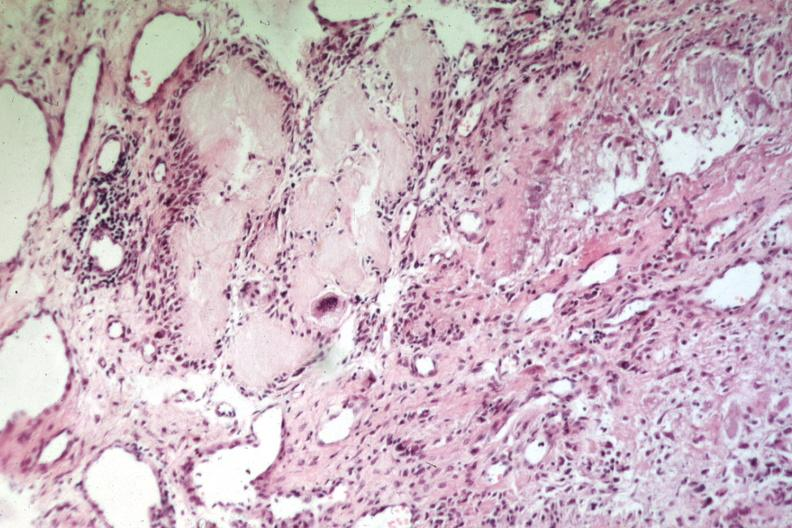where is this?
Answer the question using a single word or phrase. Skin 